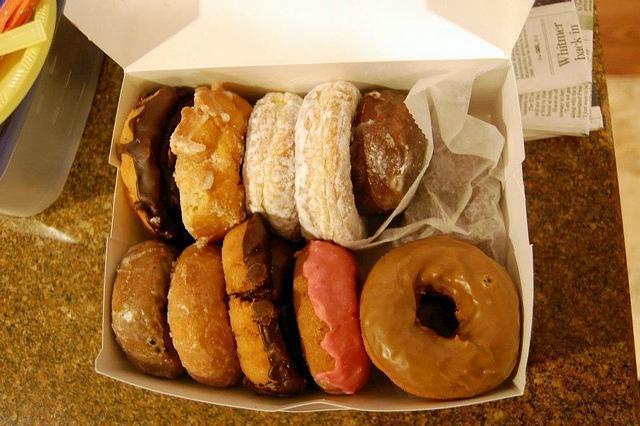How many doughnuts are there?
Give a very brief answer. 10. How many donuts can be seen?
Give a very brief answer. 10. 